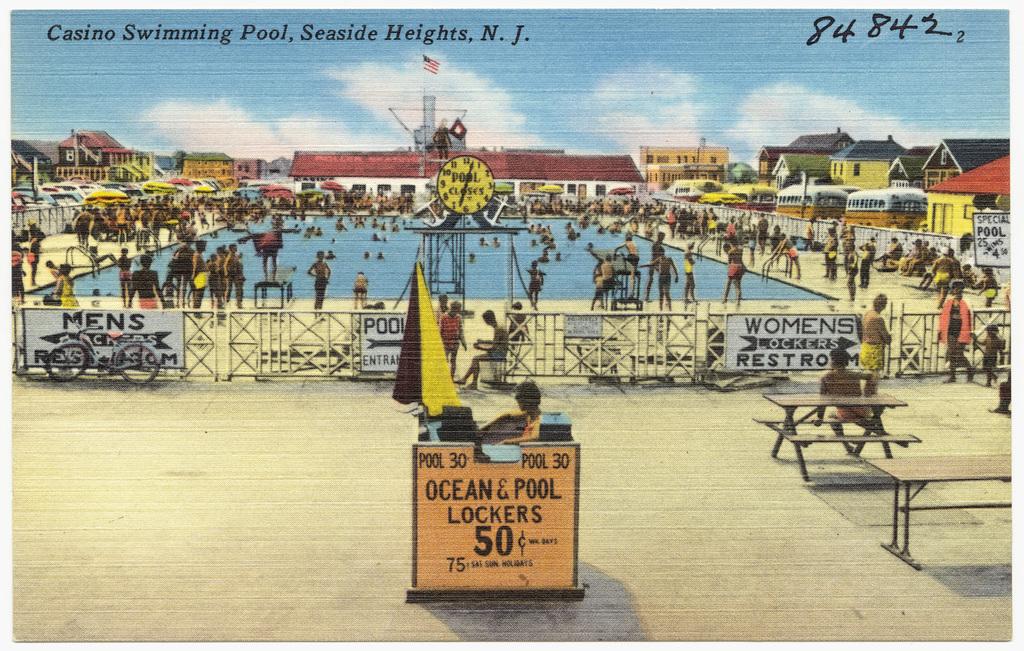How much are lockers?
Offer a very short reply. 50 cents. Which side is the men's room on?
Give a very brief answer. Left. 